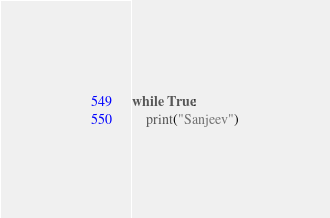Convert code to text. <code><loc_0><loc_0><loc_500><loc_500><_Python_>while True:
    print("Sanjeev")</code> 